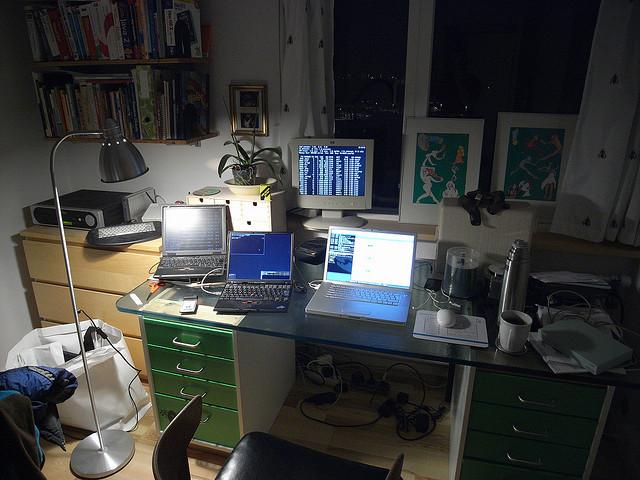What color is the table?
Write a very short answer. Clear. How many laptops in the picture?
Write a very short answer. 3. Is there enough light in this office space?
Be succinct. No. How many drawers can be seen in the picture?
Give a very brief answer. 11. 